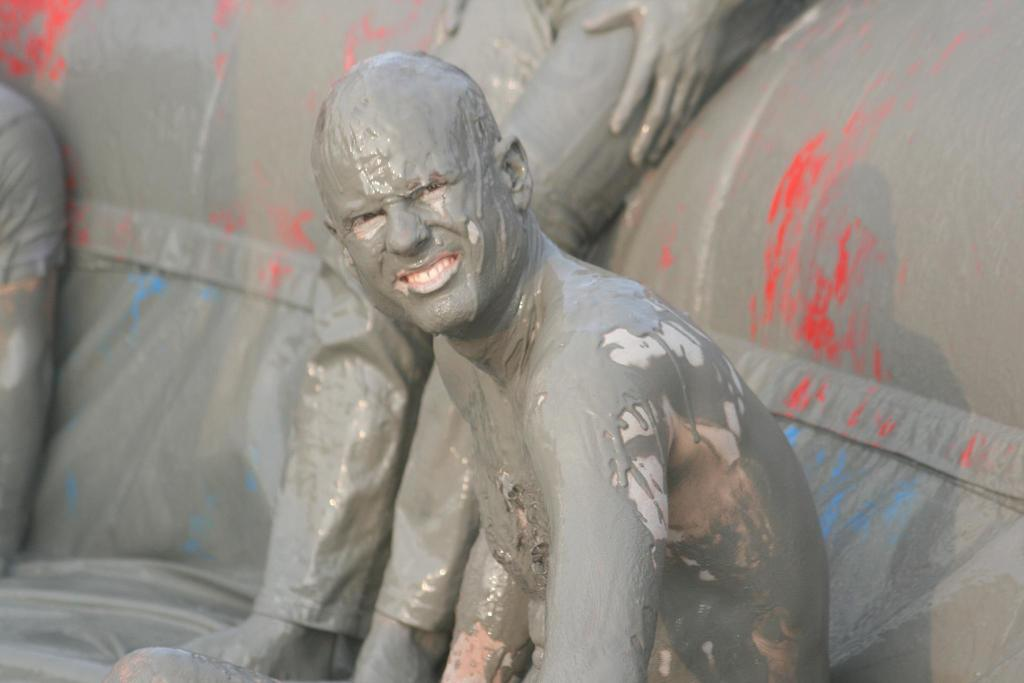What is the main subject of the image? There is a person sitting in the middle of the image. What is the person doing in the image? The person is smiling in the image. How is the person's appearance different from others in the image? The person is covered with paint. Are there any other people in the image? Yes, there are other people sitting behind the person. What type of box can be seen in the image? There is no box present in the image. How many legs does the person have in the image? The person in the image has two legs, as is typical for humans. 